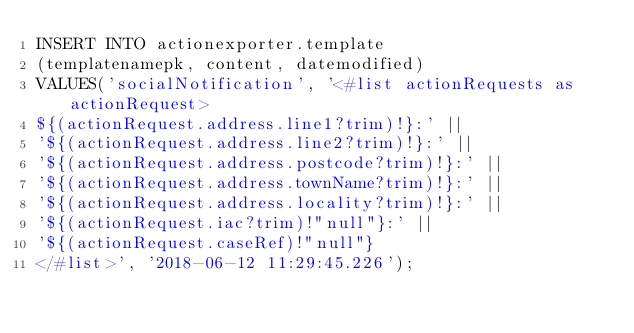<code> <loc_0><loc_0><loc_500><loc_500><_SQL_>INSERT INTO actionexporter.template
(templatenamepk, content, datemodified)
VALUES('socialNotification', '<#list actionRequests as actionRequest>
${(actionRequest.address.line1?trim)!}:' ||
'${(actionRequest.address.line2?trim)!}:' ||
'${(actionRequest.address.postcode?trim)!}:' ||
'${(actionRequest.address.townName?trim)!}:' ||
'${(actionRequest.address.locality?trim)!}:' ||
'${(actionRequest.iac?trim)!"null"}:' ||
'${(actionRequest.caseRef)!"null"}
</#list>', '2018-06-12 11:29:45.226');
</code> 